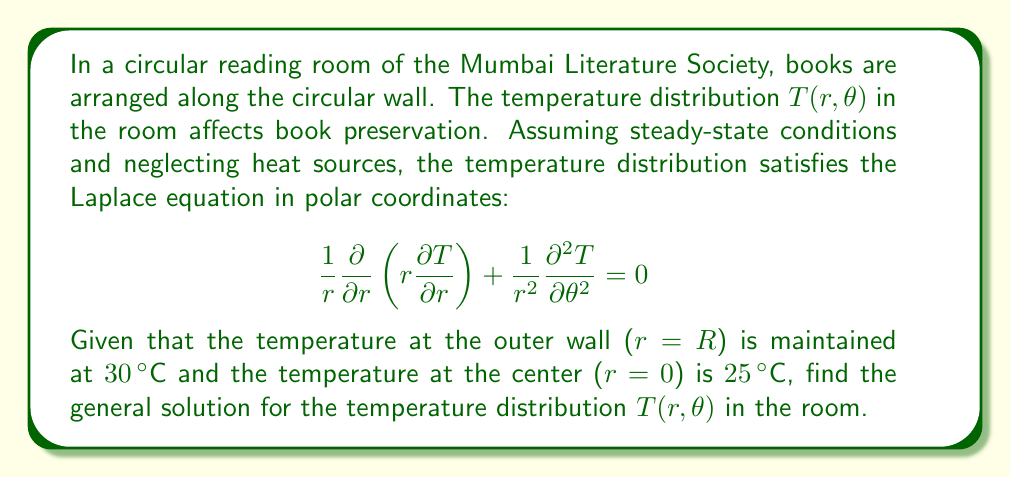Teach me how to tackle this problem. To solve this problem, we'll follow these steps:

1) The general solution of the Laplace equation in polar coordinates is:

   $$T(r,\theta) = a_0 + b_0\ln r + \sum_{n=1}^{\infty} (a_n r^n + b_n r^{-n})(c_n \cos n\theta + d_n \sin n\theta)$$

2) Given the symmetry of the problem (temperature only depends on $r$, not $\theta$), we can simplify this to:

   $$T(r) = a_0 + b_0\ln r$$

3) Now we apply the boundary conditions:
   
   At $r=0$: $T(0) = 25°C$
   At $r=R$: $T(R) = 30°C$

4) Applying the first condition:
   
   $$25 = a_0 + b_0\ln 0$$
   
   Since $\ln 0$ is undefined, we must have $b_0 = 0$ for the solution to be valid at $r=0$.
   Therefore, $a_0 = 25$.

5) Applying the second condition:
   
   $$30 = 25 + b_0\ln R$$
   
   $$5 = b_0\ln R$$
   
   $$b_0 = \frac{5}{\ln R}$$

6) Therefore, the general solution is:

   $$T(r) = 25 + \frac{5}{\ln R}\ln r$$

This solution represents the optimal temperature distribution for book preservation in the circular reading room.
Answer: $$T(r) = 25 + \frac{5}{\ln R}\ln r$$ 